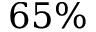<formula> <loc_0><loc_0><loc_500><loc_500>6 5 \%</formula> 